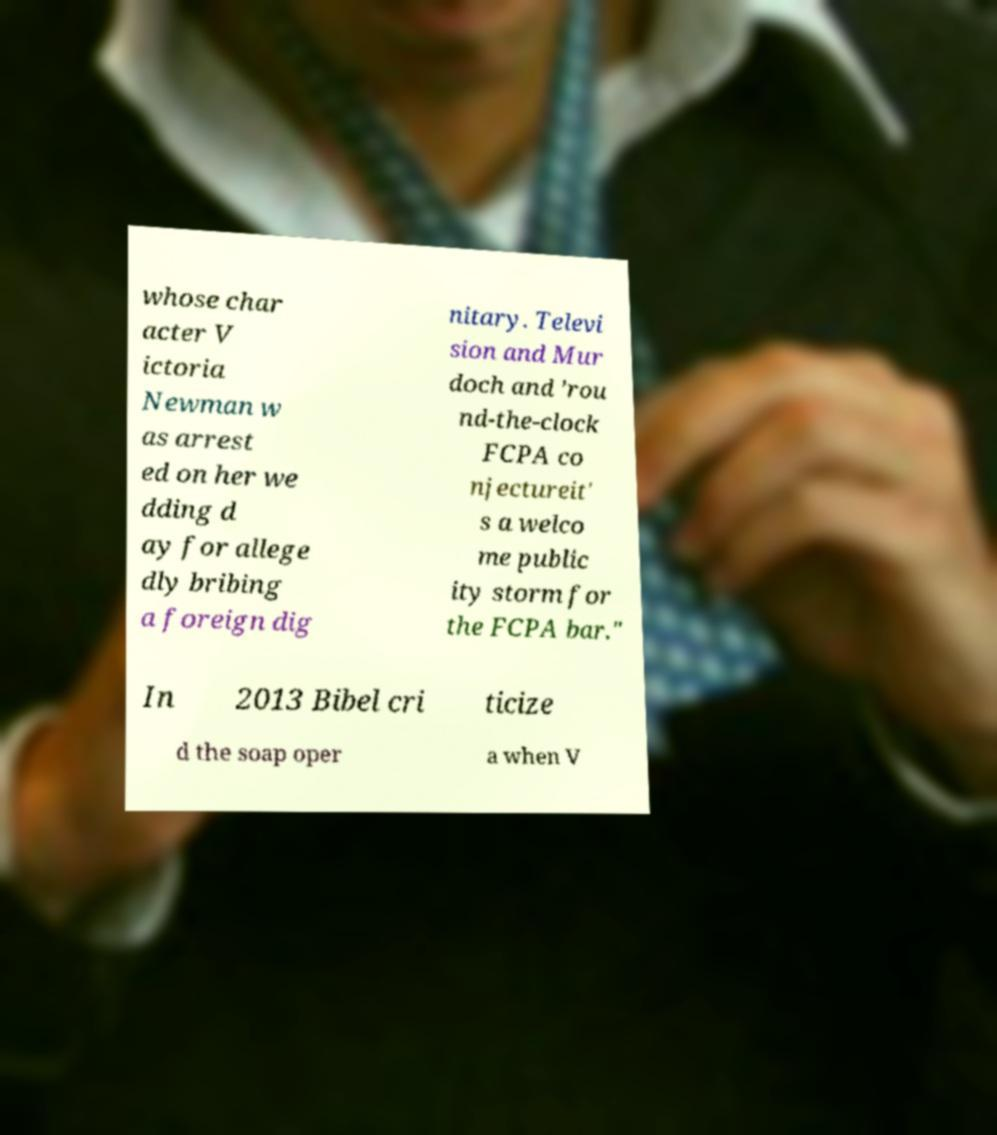Please identify and transcribe the text found in this image. whose char acter V ictoria Newman w as arrest ed on her we dding d ay for allege dly bribing a foreign dig nitary. Televi sion and Mur doch and ’rou nd-the-clock FCPA co njectureit' s a welco me public ity storm for the FCPA bar." In 2013 Bibel cri ticize d the soap oper a when V 